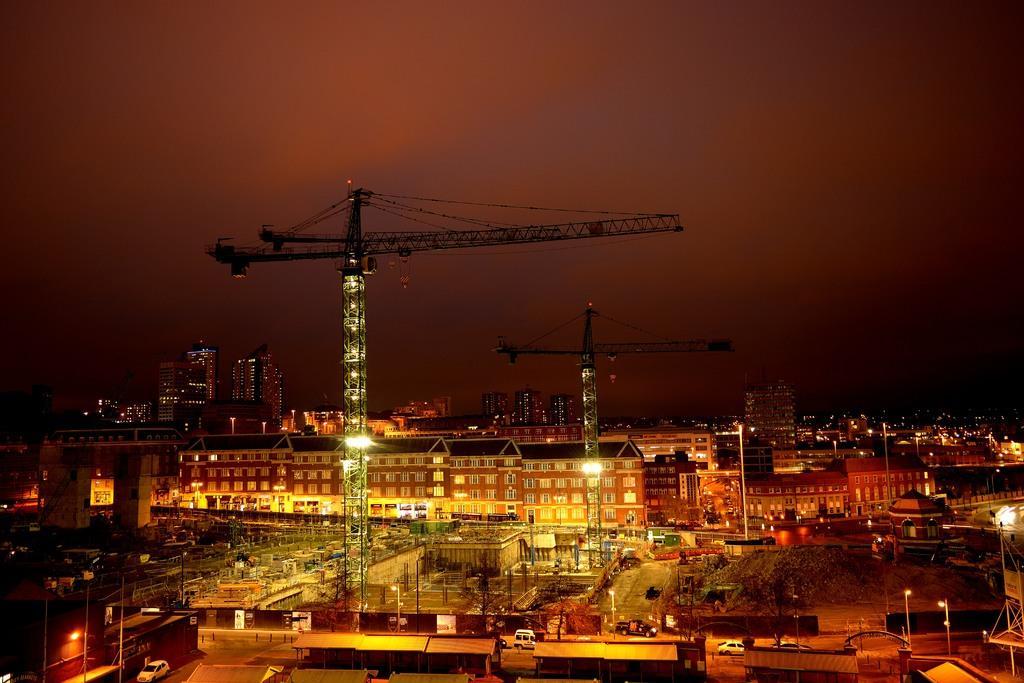In one or two sentences, can you explain what this image depicts? In this image, we can see so many buildings, houses, poles, towers, lights, trees, walls and windows. Background there is a sky. 